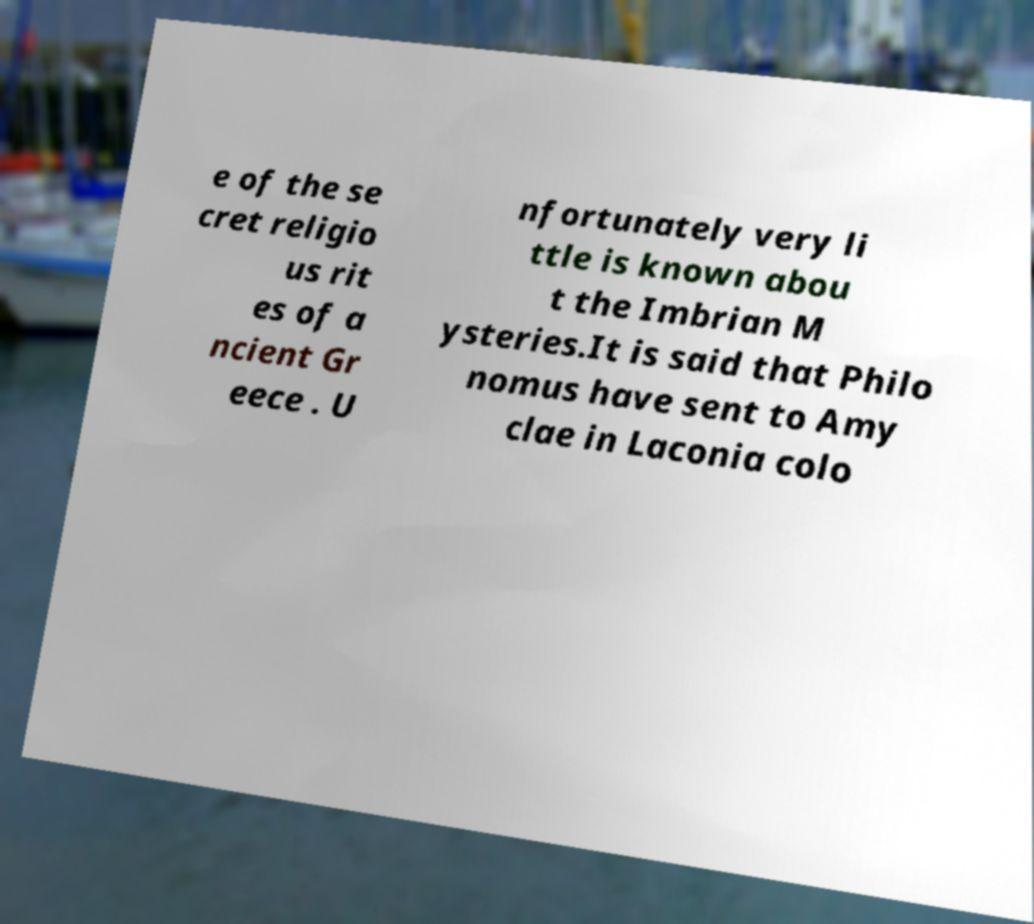There's text embedded in this image that I need extracted. Can you transcribe it verbatim? e of the se cret religio us rit es of a ncient Gr eece . U nfortunately very li ttle is known abou t the Imbrian M ysteries.It is said that Philo nomus have sent to Amy clae in Laconia colo 